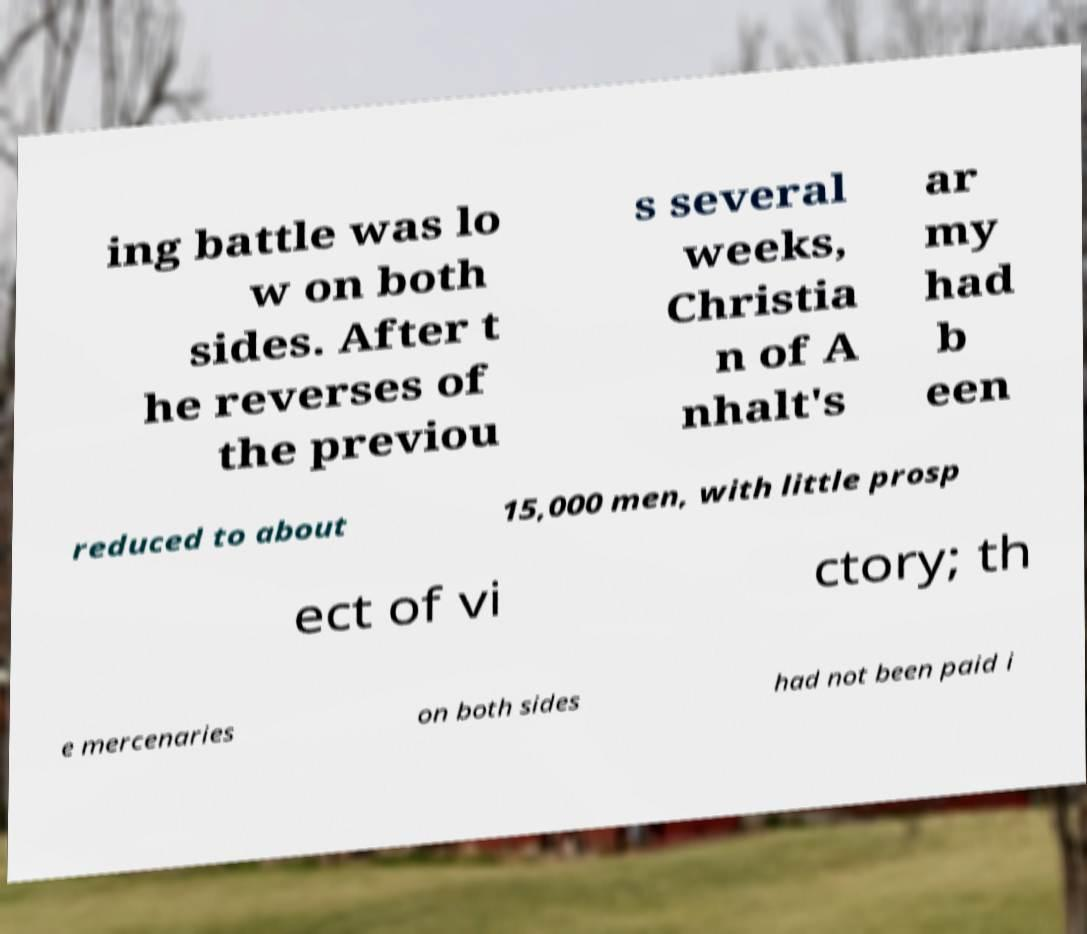What messages or text are displayed in this image? I need them in a readable, typed format. ing battle was lo w on both sides. After t he reverses of the previou s several weeks, Christia n of A nhalt's ar my had b een reduced to about 15,000 men, with little prosp ect of vi ctory; th e mercenaries on both sides had not been paid i 